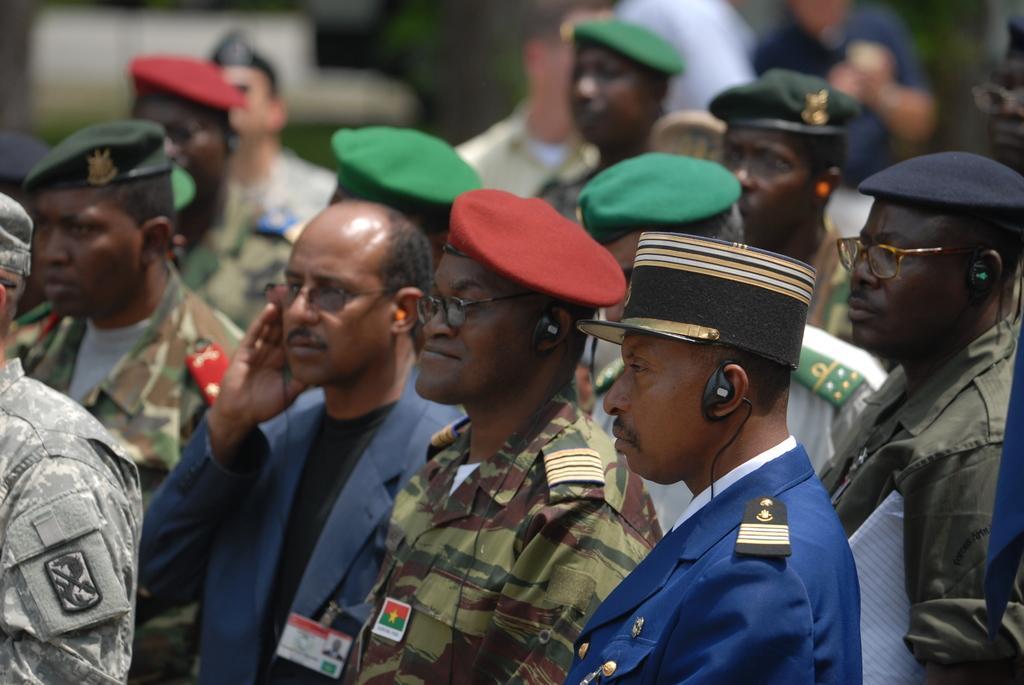Can you describe this image briefly? In this image there are group of persons standing, there are persons wearing caps, there are persons holding an object, there are persons truncated towards the bottom of the image, there are persons truncated towards the left of the image,there is a person's truncated towards the right of the image, there is an object truncated towards the right of the image, the background of the image is blurred. 